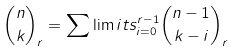Convert formula to latex. <formula><loc_0><loc_0><loc_500><loc_500>\binom { n } { k } _ { r } = \sum \lim i t s _ { i = 0 } ^ { r - 1 } \binom { n - 1 } { k - i } _ { r }</formula> 